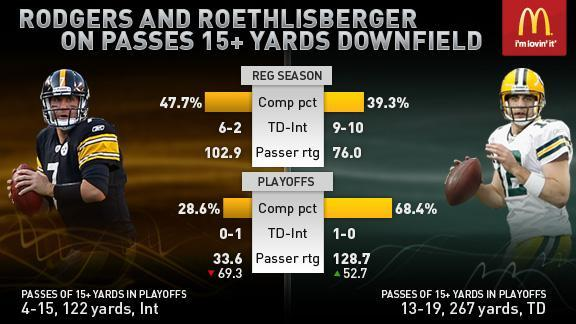What is the helmet colour of the player in white jersey, black or yellow
Answer the question with a short phrase. yellow What is the colour of the rugby ball, brown or white brown 